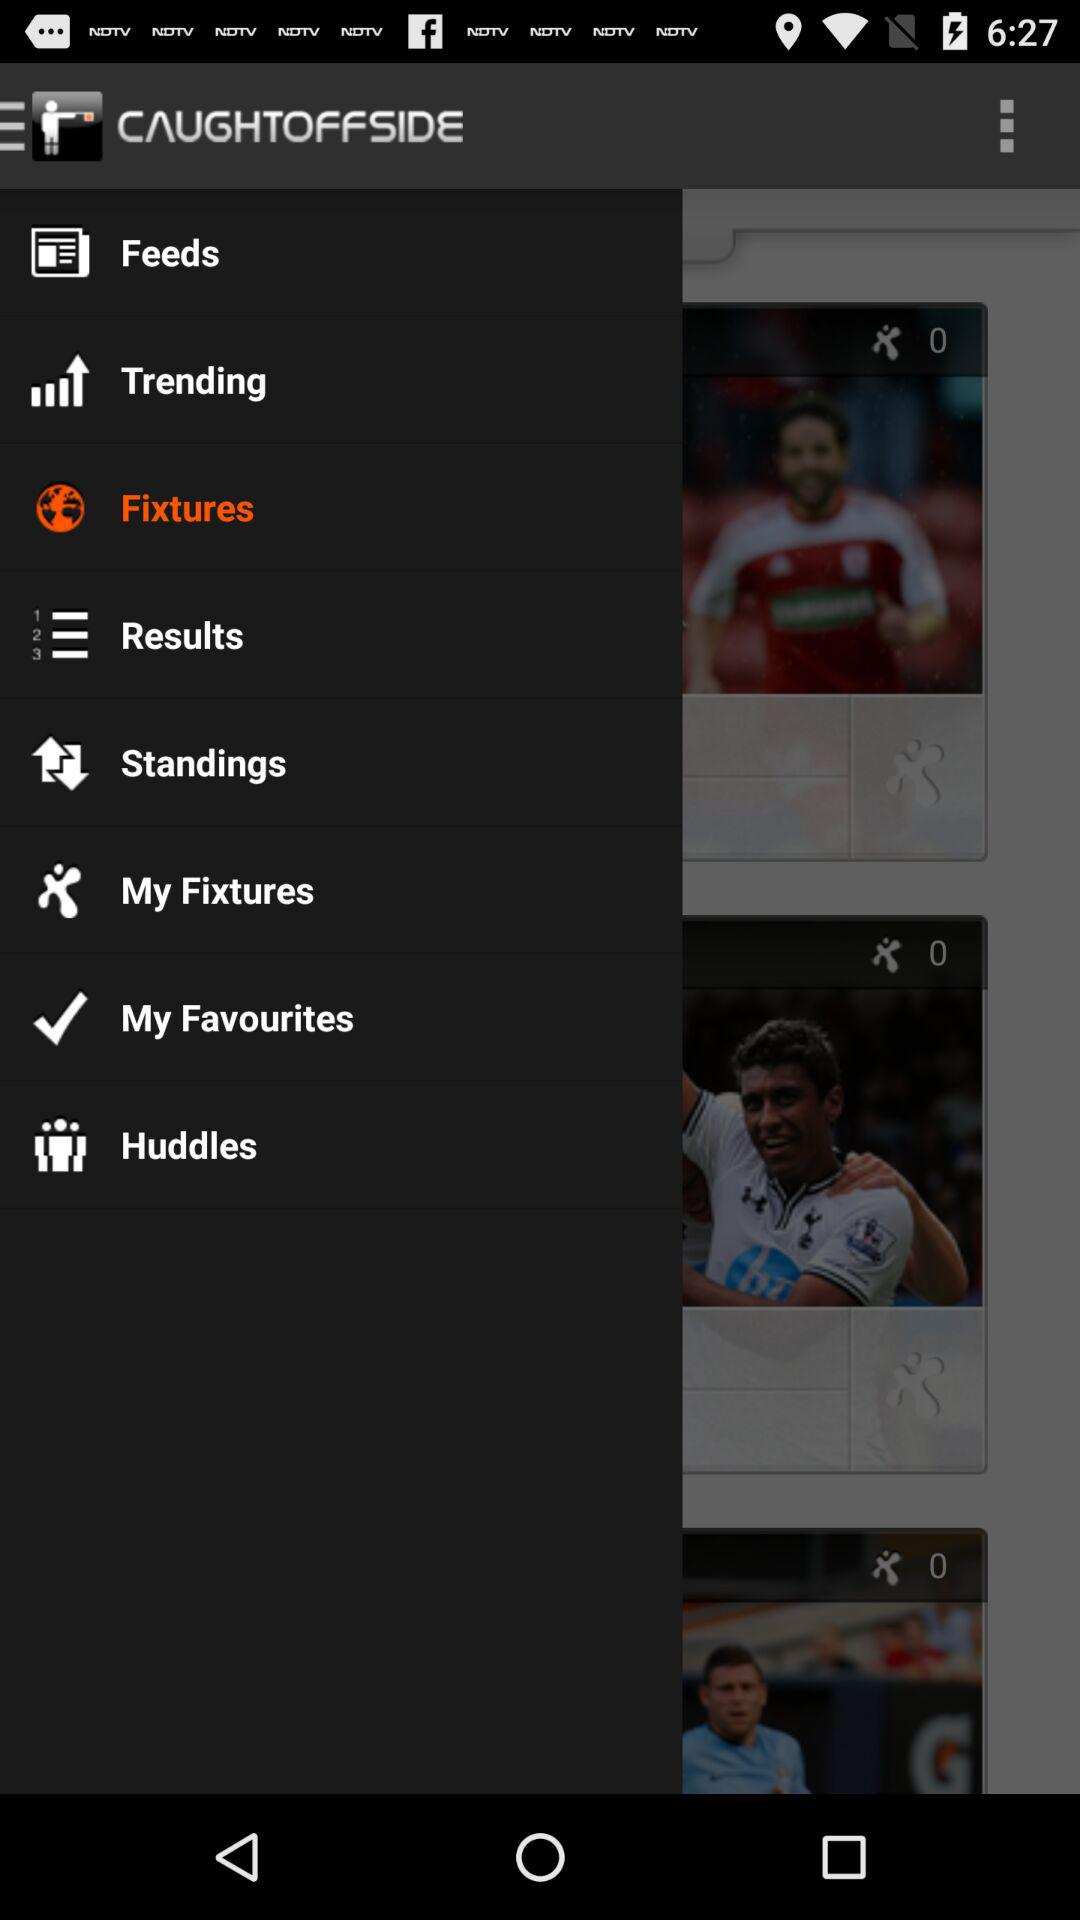What is the application name? The application name is "CAUGHTOFFSIDE". 